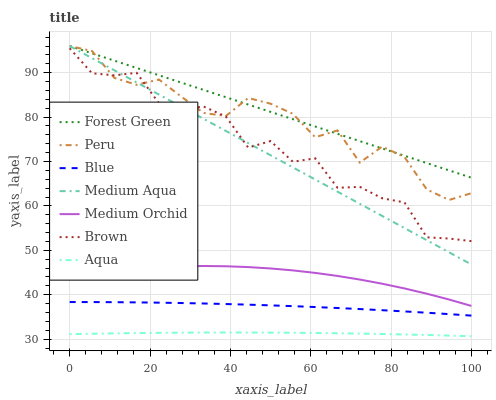Does Aqua have the minimum area under the curve?
Answer yes or no. Yes. Does Forest Green have the maximum area under the curve?
Answer yes or no. Yes. Does Brown have the minimum area under the curve?
Answer yes or no. No. Does Brown have the maximum area under the curve?
Answer yes or no. No. Is Forest Green the smoothest?
Answer yes or no. Yes. Is Brown the roughest?
Answer yes or no. Yes. Is Medium Orchid the smoothest?
Answer yes or no. No. Is Medium Orchid the roughest?
Answer yes or no. No. Does Aqua have the lowest value?
Answer yes or no. Yes. Does Brown have the lowest value?
Answer yes or no. No. Does Peru have the highest value?
Answer yes or no. Yes. Does Brown have the highest value?
Answer yes or no. No. Is Aqua less than Medium Aqua?
Answer yes or no. Yes. Is Peru greater than Blue?
Answer yes or no. Yes. Does Medium Aqua intersect Forest Green?
Answer yes or no. Yes. Is Medium Aqua less than Forest Green?
Answer yes or no. No. Is Medium Aqua greater than Forest Green?
Answer yes or no. No. Does Aqua intersect Medium Aqua?
Answer yes or no. No. 